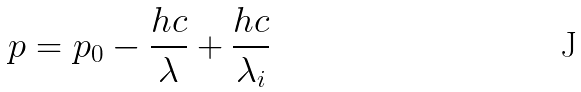<formula> <loc_0><loc_0><loc_500><loc_500>p = p _ { 0 } - \frac { h c } { \lambda } + \frac { h c } { \lambda _ { i } }</formula> 